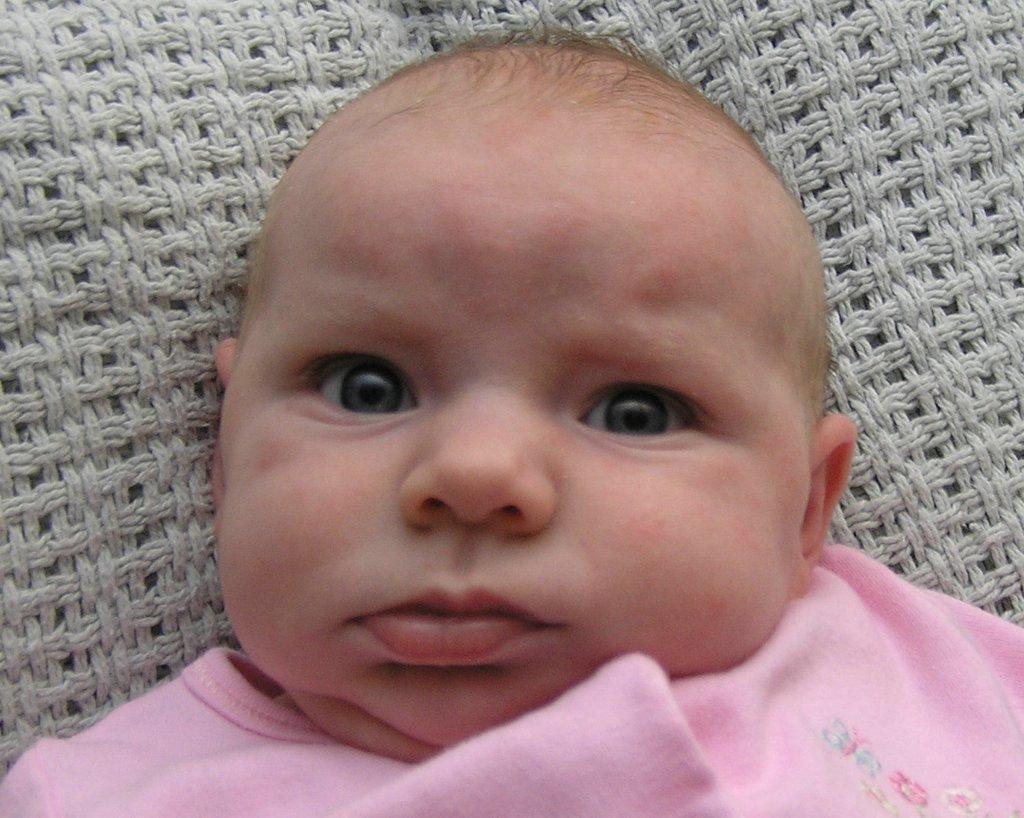In one or two sentences, can you explain what this image depicts? In this image I can see a baby and I can see this baby is wearing pink colour cloth. I can also see a cloth under the baby. 